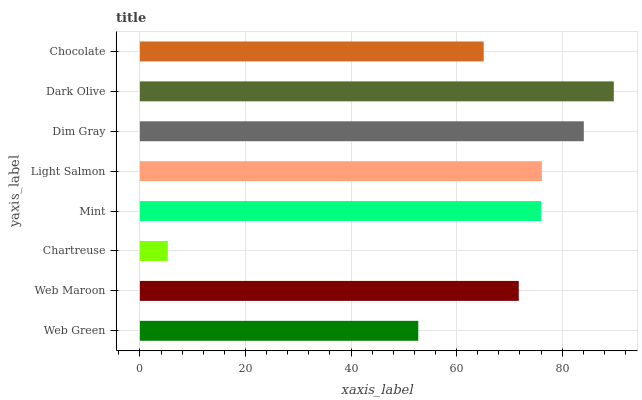Is Chartreuse the minimum?
Answer yes or no. Yes. Is Dark Olive the maximum?
Answer yes or no. Yes. Is Web Maroon the minimum?
Answer yes or no. No. Is Web Maroon the maximum?
Answer yes or no. No. Is Web Maroon greater than Web Green?
Answer yes or no. Yes. Is Web Green less than Web Maroon?
Answer yes or no. Yes. Is Web Green greater than Web Maroon?
Answer yes or no. No. Is Web Maroon less than Web Green?
Answer yes or no. No. Is Mint the high median?
Answer yes or no. Yes. Is Web Maroon the low median?
Answer yes or no. Yes. Is Web Green the high median?
Answer yes or no. No. Is Chartreuse the low median?
Answer yes or no. No. 